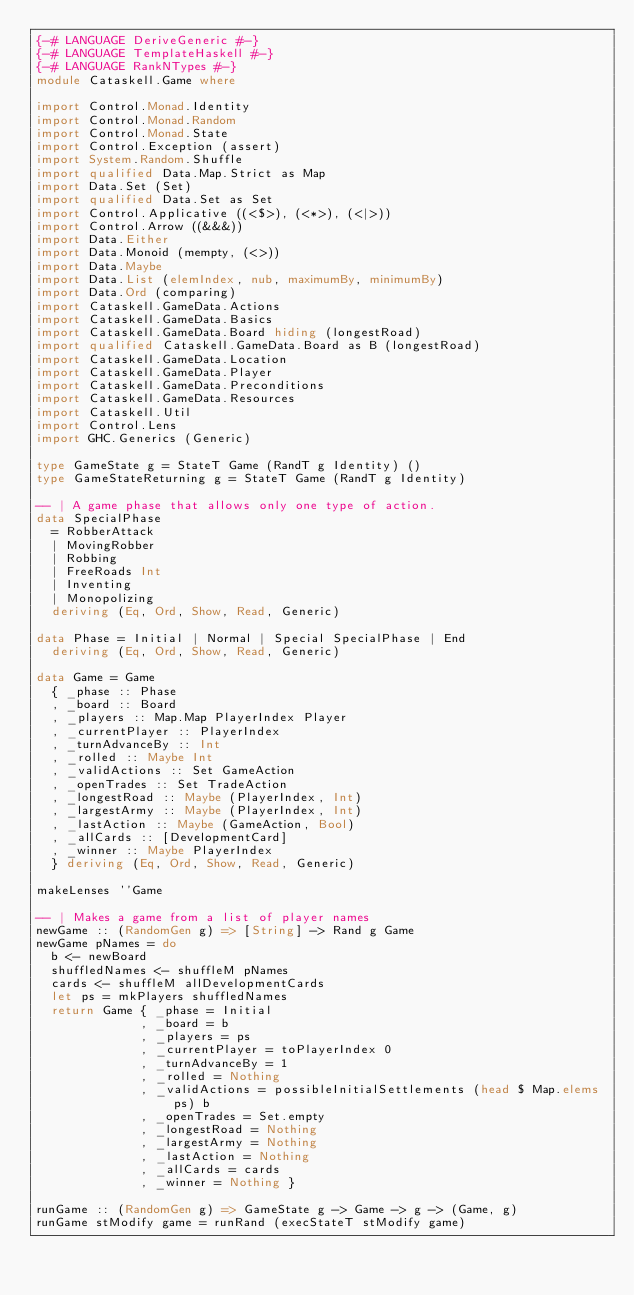<code> <loc_0><loc_0><loc_500><loc_500><_Haskell_>{-# LANGUAGE DeriveGeneric #-}
{-# LANGUAGE TemplateHaskell #-}
{-# LANGUAGE RankNTypes #-}
module Cataskell.Game where

import Control.Monad.Identity
import Control.Monad.Random
import Control.Monad.State
import Control.Exception (assert)
import System.Random.Shuffle
import qualified Data.Map.Strict as Map
import Data.Set (Set)
import qualified Data.Set as Set
import Control.Applicative ((<$>), (<*>), (<|>))
import Control.Arrow ((&&&))
import Data.Either
import Data.Monoid (mempty, (<>))
import Data.Maybe
import Data.List (elemIndex, nub, maximumBy, minimumBy)
import Data.Ord (comparing)
import Cataskell.GameData.Actions
import Cataskell.GameData.Basics
import Cataskell.GameData.Board hiding (longestRoad)
import qualified Cataskell.GameData.Board as B (longestRoad)
import Cataskell.GameData.Location
import Cataskell.GameData.Player
import Cataskell.GameData.Preconditions
import Cataskell.GameData.Resources
import Cataskell.Util
import Control.Lens
import GHC.Generics (Generic)

type GameState g = StateT Game (RandT g Identity) ()
type GameStateReturning g = StateT Game (RandT g Identity)

-- | A game phase that allows only one type of action.
data SpecialPhase
  = RobberAttack
  | MovingRobber
  | Robbing
  | FreeRoads Int
  | Inventing
  | Monopolizing
  deriving (Eq, Ord, Show, Read, Generic)

data Phase = Initial | Normal | Special SpecialPhase | End
  deriving (Eq, Ord, Show, Read, Generic)

data Game = Game
  { _phase :: Phase
  , _board :: Board
  , _players :: Map.Map PlayerIndex Player
  , _currentPlayer :: PlayerIndex
  , _turnAdvanceBy :: Int
  , _rolled :: Maybe Int
  , _validActions :: Set GameAction
  , _openTrades :: Set TradeAction
  , _longestRoad :: Maybe (PlayerIndex, Int)
  , _largestArmy :: Maybe (PlayerIndex, Int)
  , _lastAction :: Maybe (GameAction, Bool)
  , _allCards :: [DevelopmentCard]
  , _winner :: Maybe PlayerIndex
  } deriving (Eq, Ord, Show, Read, Generic)

makeLenses ''Game

-- | Makes a game from a list of player names
newGame :: (RandomGen g) => [String] -> Rand g Game
newGame pNames = do
  b <- newBoard
  shuffledNames <- shuffleM pNames
  cards <- shuffleM allDevelopmentCards
  let ps = mkPlayers shuffledNames
  return Game { _phase = Initial
              , _board = b
              , _players = ps
              , _currentPlayer = toPlayerIndex 0
              , _turnAdvanceBy = 1
              , _rolled = Nothing
              , _validActions = possibleInitialSettlements (head $ Map.elems ps) b
              , _openTrades = Set.empty
              , _longestRoad = Nothing
              , _largestArmy = Nothing
              , _lastAction = Nothing
              , _allCards = cards
              , _winner = Nothing }

runGame :: (RandomGen g) => GameState g -> Game -> g -> (Game, g)
runGame stModify game = runRand (execStateT stModify game)
</code> 